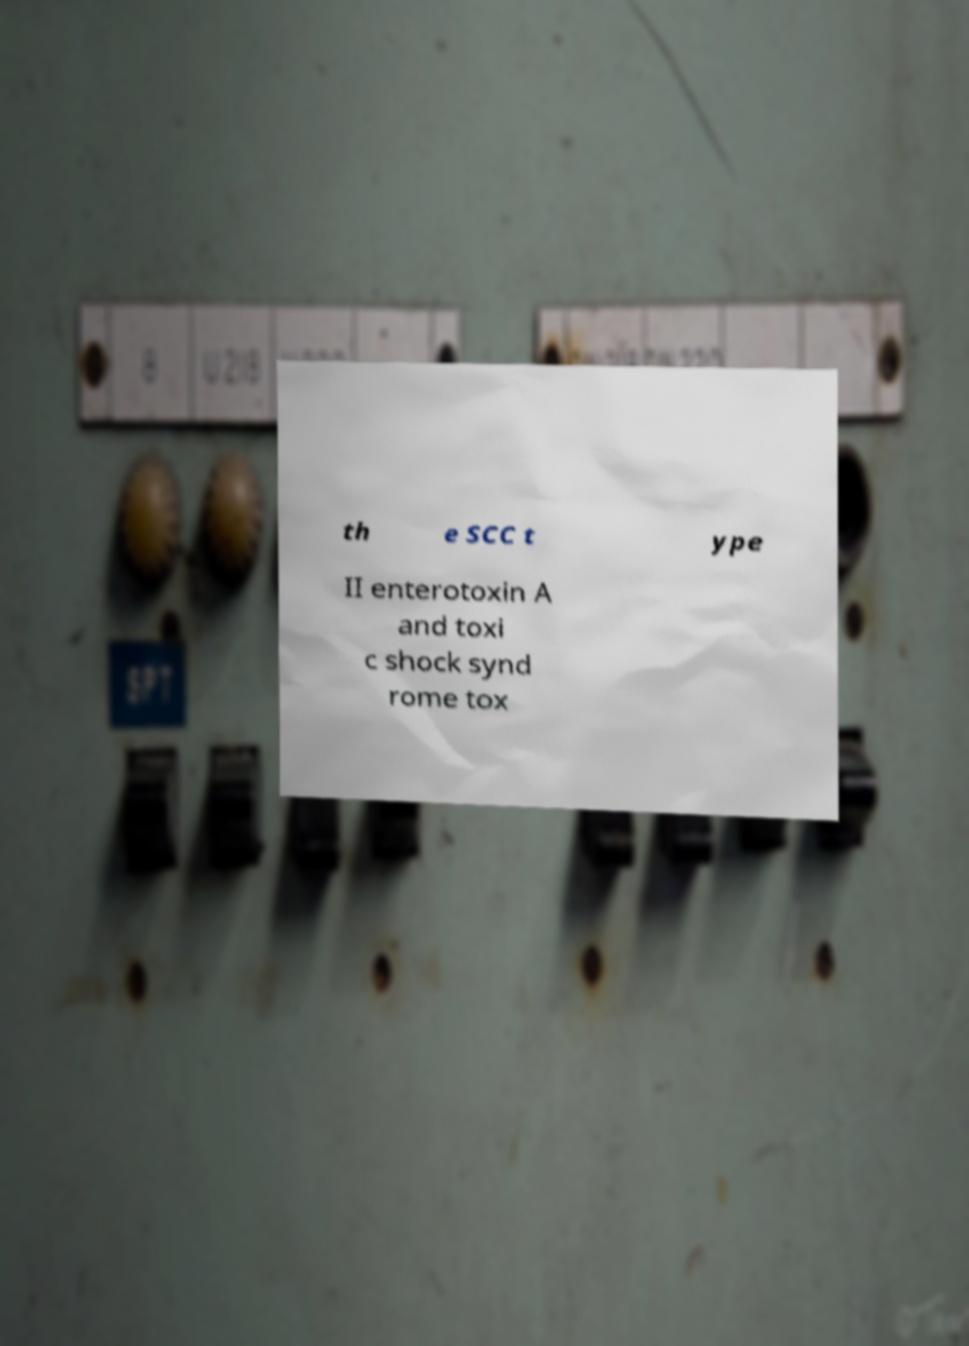Can you accurately transcribe the text from the provided image for me? th e SCC t ype II enterotoxin A and toxi c shock synd rome tox 